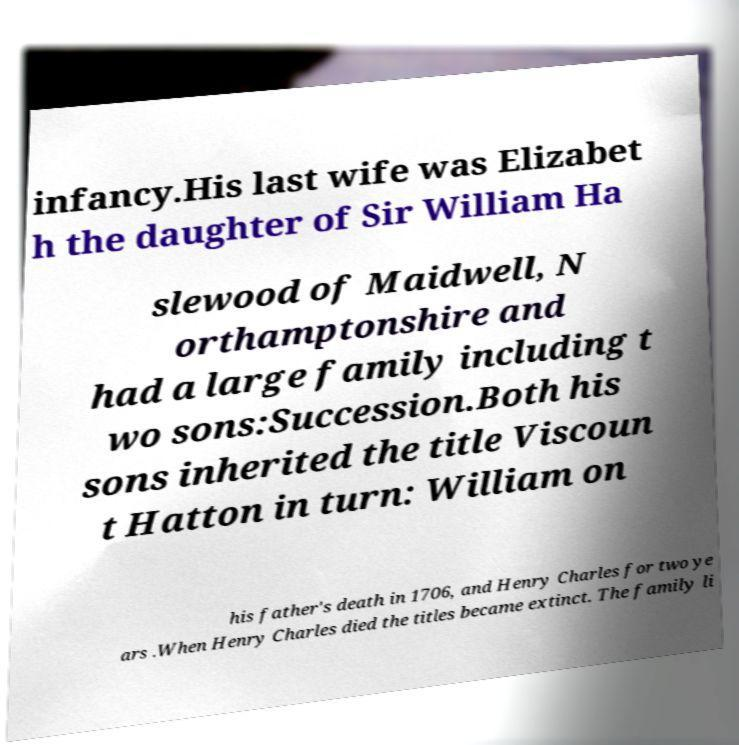Could you assist in decoding the text presented in this image and type it out clearly? infancy.His last wife was Elizabet h the daughter of Sir William Ha slewood of Maidwell, N orthamptonshire and had a large family including t wo sons:Succession.Both his sons inherited the title Viscoun t Hatton in turn: William on his father's death in 1706, and Henry Charles for two ye ars .When Henry Charles died the titles became extinct. The family li 